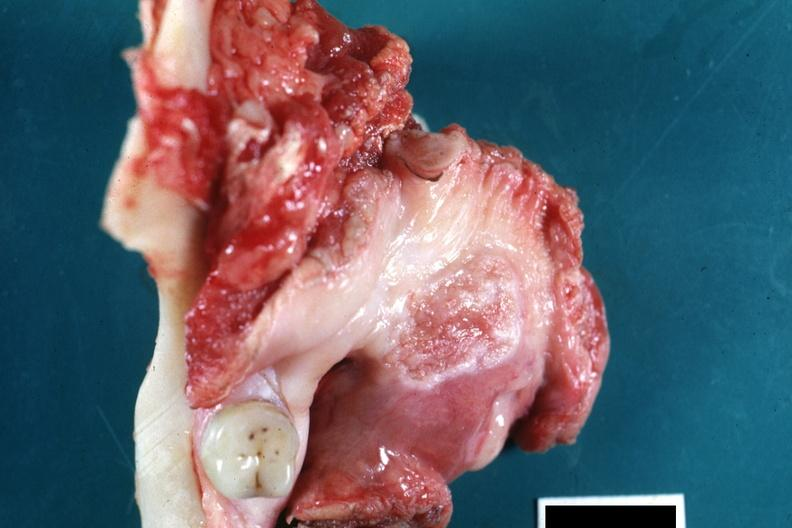where is this?
Answer the question using a single word or phrase. Oral 